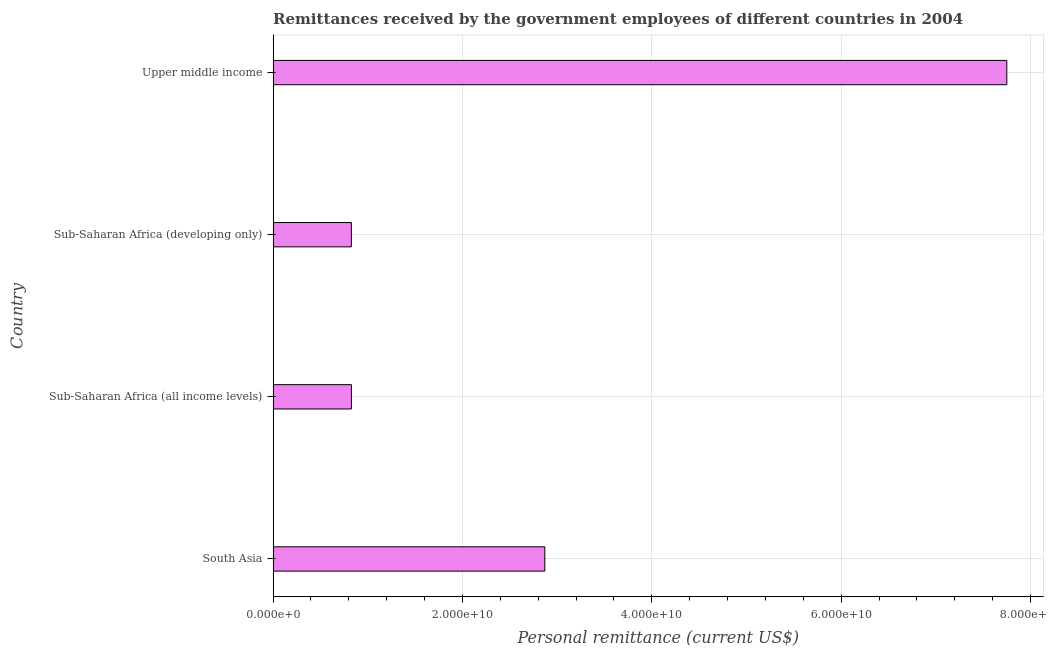Does the graph contain any zero values?
Your answer should be compact. No. What is the title of the graph?
Provide a short and direct response. Remittances received by the government employees of different countries in 2004. What is the label or title of the X-axis?
Offer a terse response. Personal remittance (current US$). What is the personal remittances in Sub-Saharan Africa (all income levels)?
Your answer should be very brief. 8.27e+09. Across all countries, what is the maximum personal remittances?
Your answer should be compact. 7.75e+1. Across all countries, what is the minimum personal remittances?
Your answer should be compact. 8.26e+09. In which country was the personal remittances maximum?
Keep it short and to the point. Upper middle income. In which country was the personal remittances minimum?
Your answer should be very brief. Sub-Saharan Africa (developing only). What is the sum of the personal remittances?
Provide a short and direct response. 1.23e+11. What is the difference between the personal remittances in Sub-Saharan Africa (all income levels) and Sub-Saharan Africa (developing only)?
Ensure brevity in your answer.  6.81e+06. What is the average personal remittances per country?
Give a very brief answer. 3.07e+1. What is the median personal remittances?
Offer a terse response. 1.85e+1. In how many countries, is the personal remittances greater than 68000000000 US$?
Keep it short and to the point. 1. What is the ratio of the personal remittances in Sub-Saharan Africa (all income levels) to that in Upper middle income?
Give a very brief answer. 0.11. Is the difference between the personal remittances in Sub-Saharan Africa (all income levels) and Upper middle income greater than the difference between any two countries?
Provide a short and direct response. No. What is the difference between the highest and the second highest personal remittances?
Your answer should be very brief. 4.88e+1. What is the difference between the highest and the lowest personal remittances?
Make the answer very short. 6.92e+1. Are all the bars in the graph horizontal?
Provide a succinct answer. Yes. What is the Personal remittance (current US$) in South Asia?
Make the answer very short. 2.87e+1. What is the Personal remittance (current US$) of Sub-Saharan Africa (all income levels)?
Provide a short and direct response. 8.27e+09. What is the Personal remittance (current US$) in Sub-Saharan Africa (developing only)?
Offer a very short reply. 8.26e+09. What is the Personal remittance (current US$) in Upper middle income?
Offer a very short reply. 7.75e+1. What is the difference between the Personal remittance (current US$) in South Asia and Sub-Saharan Africa (all income levels)?
Give a very brief answer. 2.04e+1. What is the difference between the Personal remittance (current US$) in South Asia and Sub-Saharan Africa (developing only)?
Provide a short and direct response. 2.04e+1. What is the difference between the Personal remittance (current US$) in South Asia and Upper middle income?
Make the answer very short. -4.88e+1. What is the difference between the Personal remittance (current US$) in Sub-Saharan Africa (all income levels) and Sub-Saharan Africa (developing only)?
Your answer should be very brief. 6.81e+06. What is the difference between the Personal remittance (current US$) in Sub-Saharan Africa (all income levels) and Upper middle income?
Give a very brief answer. -6.92e+1. What is the difference between the Personal remittance (current US$) in Sub-Saharan Africa (developing only) and Upper middle income?
Provide a succinct answer. -6.92e+1. What is the ratio of the Personal remittance (current US$) in South Asia to that in Sub-Saharan Africa (all income levels)?
Keep it short and to the point. 3.47. What is the ratio of the Personal remittance (current US$) in South Asia to that in Sub-Saharan Africa (developing only)?
Offer a very short reply. 3.47. What is the ratio of the Personal remittance (current US$) in South Asia to that in Upper middle income?
Offer a very short reply. 0.37. What is the ratio of the Personal remittance (current US$) in Sub-Saharan Africa (all income levels) to that in Sub-Saharan Africa (developing only)?
Offer a terse response. 1. What is the ratio of the Personal remittance (current US$) in Sub-Saharan Africa (all income levels) to that in Upper middle income?
Provide a short and direct response. 0.11. What is the ratio of the Personal remittance (current US$) in Sub-Saharan Africa (developing only) to that in Upper middle income?
Provide a succinct answer. 0.11. 